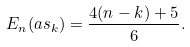Convert formula to latex. <formula><loc_0><loc_0><loc_500><loc_500>E _ { n } ( a s _ { k } ) = \frac { 4 ( n - k ) + 5 } { 6 } .</formula> 